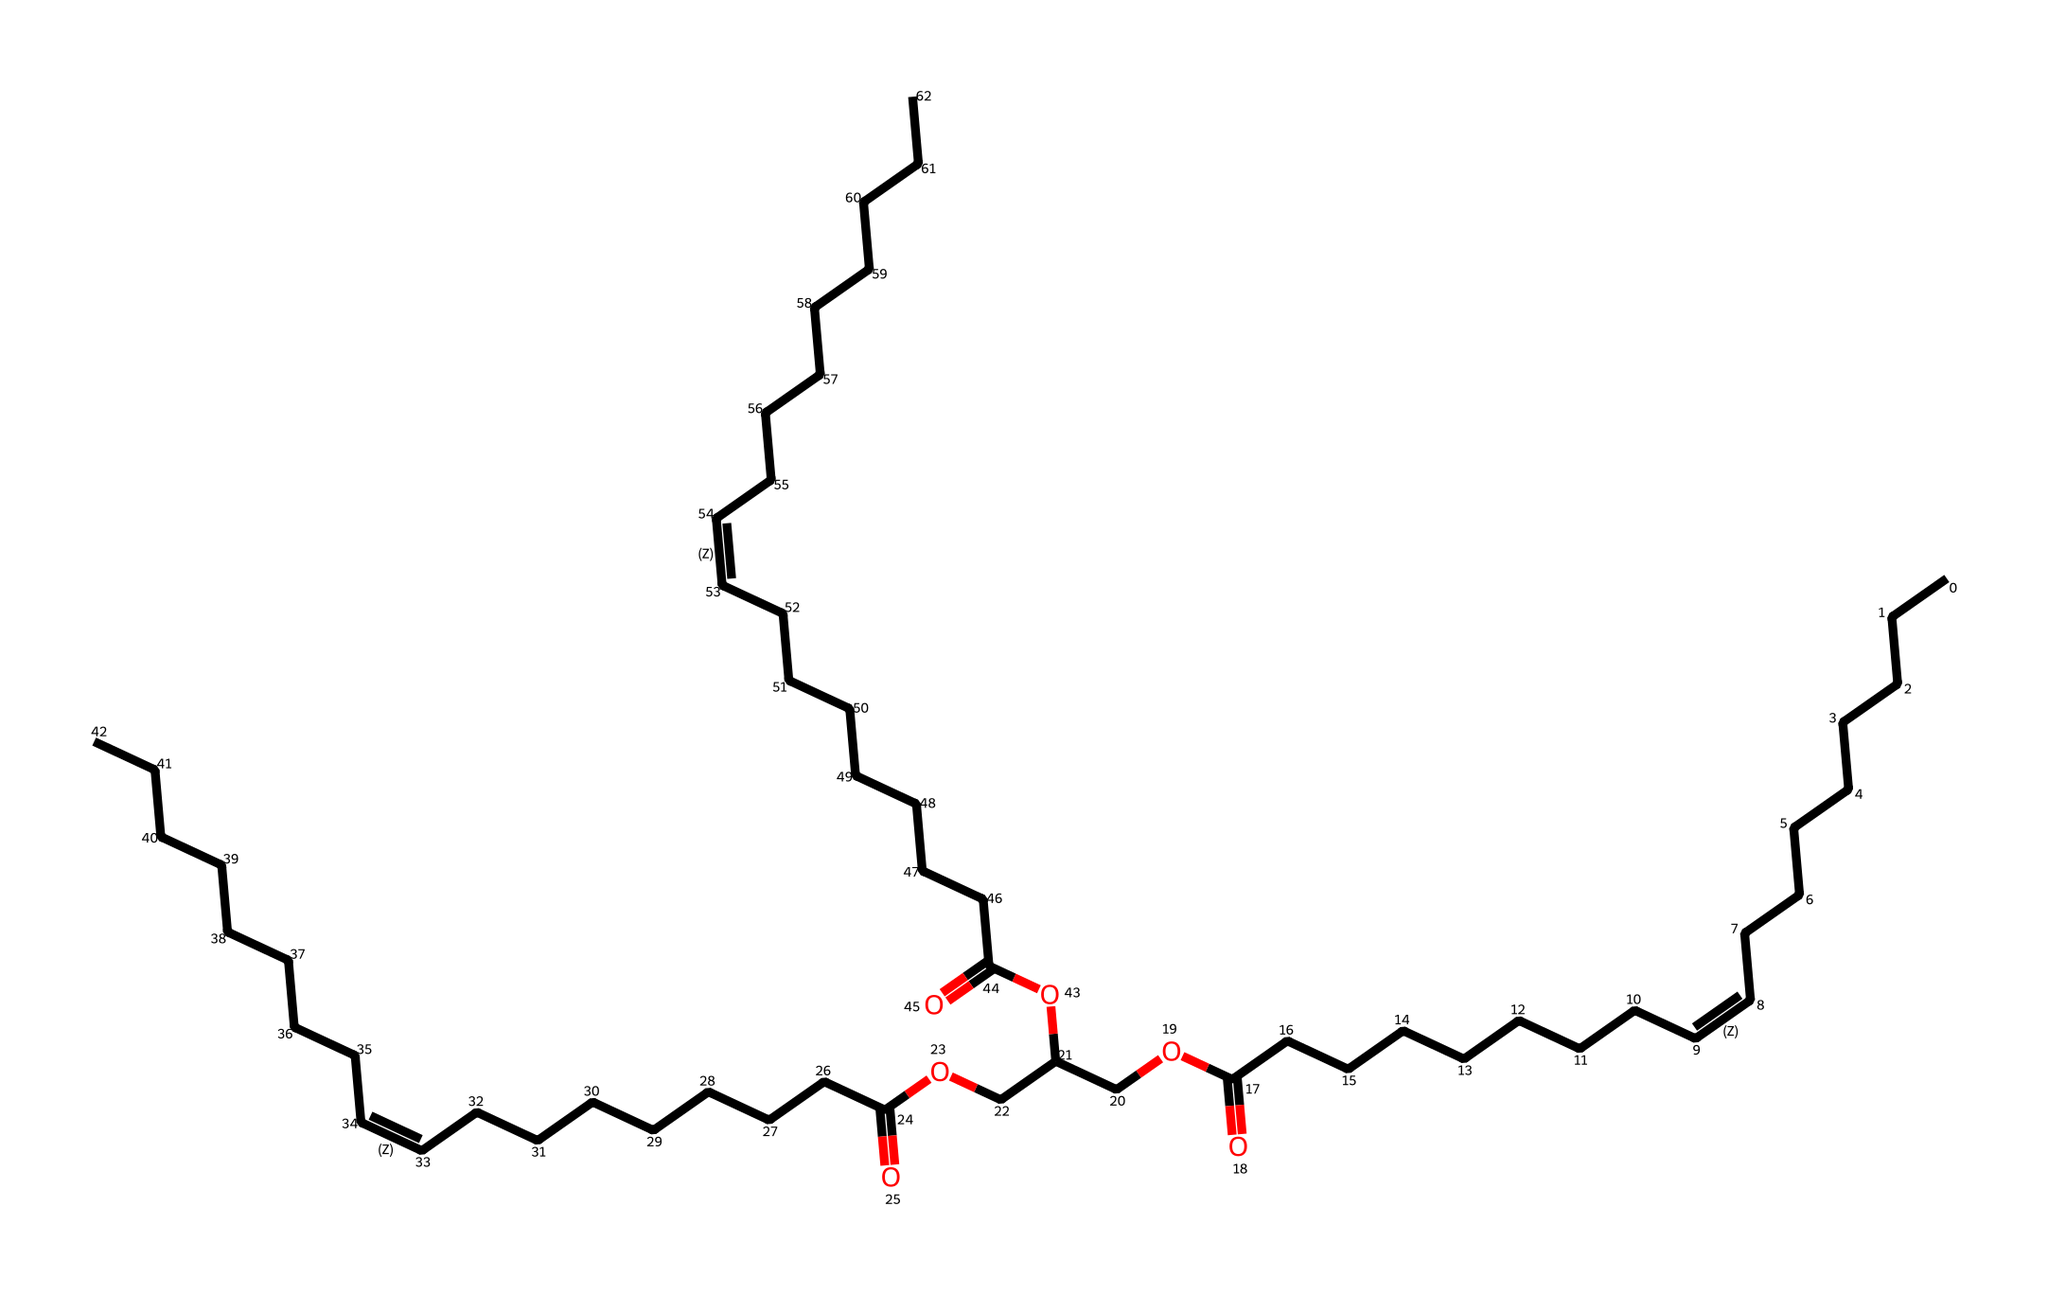What type of lipid is represented by this structure? The chemical structure contains long hydrocarbon chains with multiple double bonds, typical of unsaturated fatty acids, indicating it is a triglyceride or a phospholipid.
Answer: unsaturated fatty acid How many double bonds are present in this chemical structure? By examining the SMILES representation, you can identify the occurrences of "/C=C\" which indicates the presence of double bonds. Counting these bonds reveals that there are three double bonds in total.
Answer: three What is the total number of carbon atoms in this molecule? The structure can be analyzed by counting the number of carbon atoms present in the hydrocarbon chains indicated by the symbols "C" in the SMILES. There are a total of 54 carbon atoms in the entire molecule.
Answer: fifty-four How is this chemical primarily used in relation to fabric softeners? This compound is derived from soybean oil, which is commonly used in fabric softeners for its emulsifying and conditioning properties, helping to soften fabrics and reduce static.
Answer: emulsifying and conditioning properties What functional group is present in this chemical structure, indicating its acidic properties? The structure includes the -COOH portion, which is characteristic of carboxylic acids. Identifying this functional group demonstrates the acidity of the compound.
Answer: carboxylic acid 